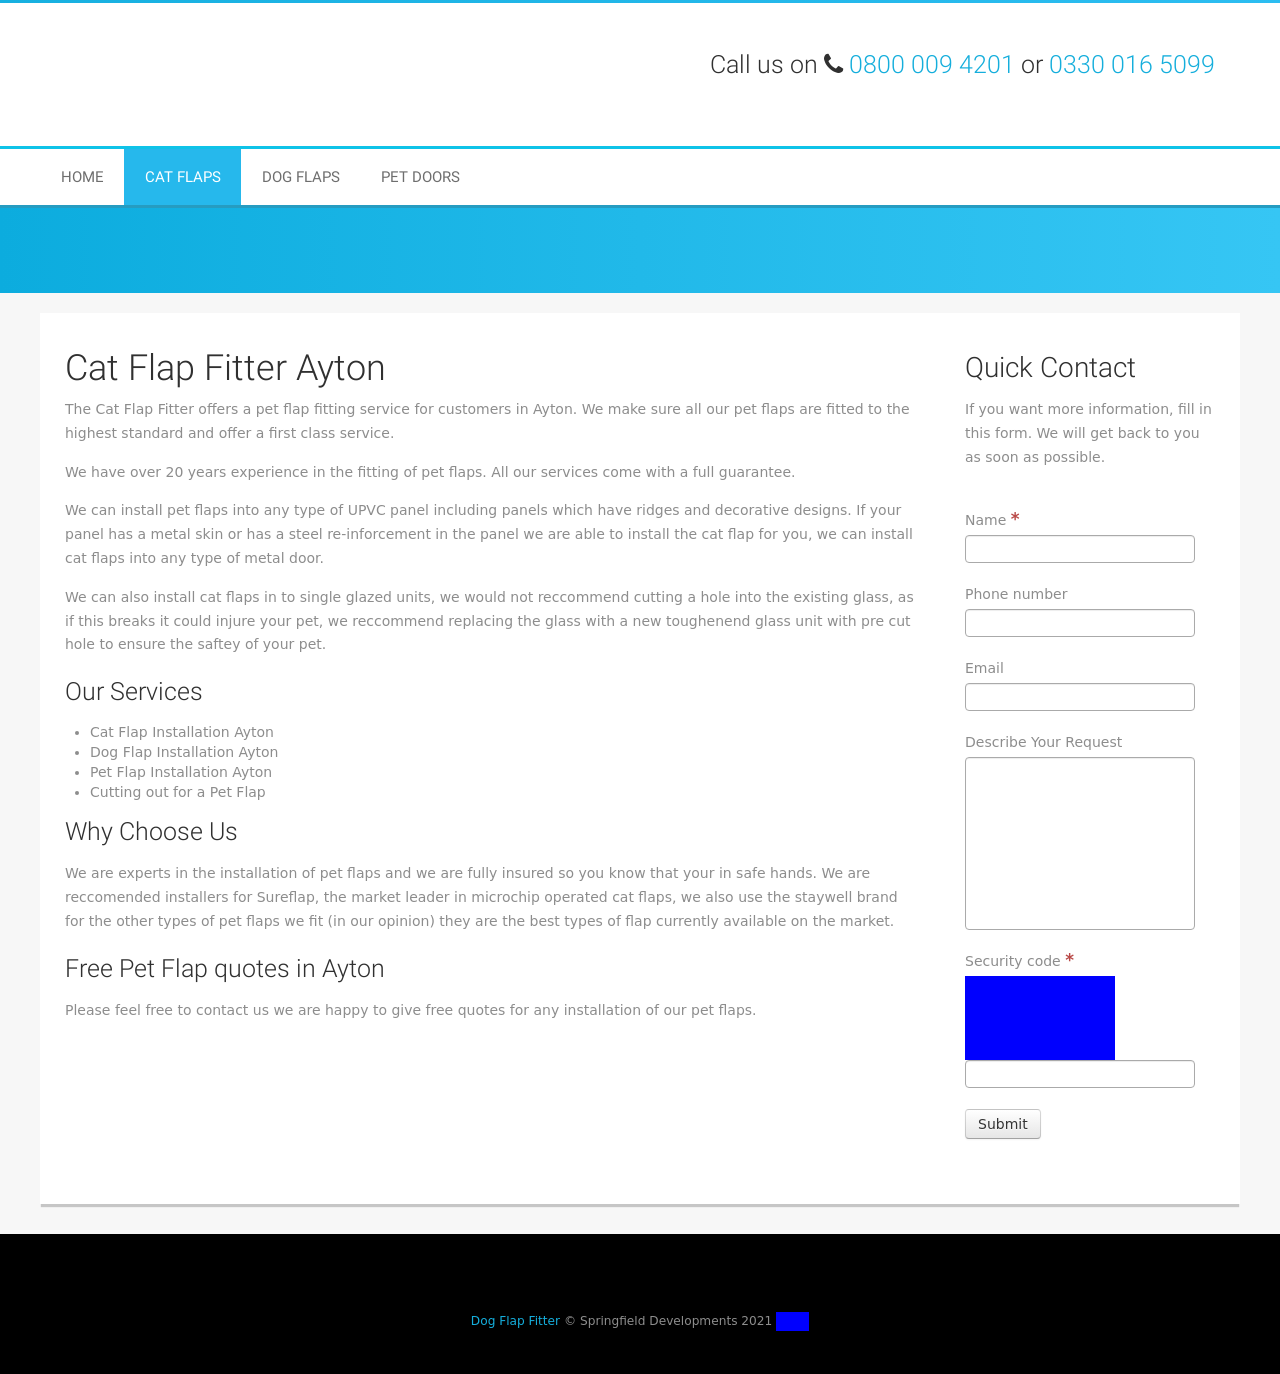What type of materials is this website promoting for pet flap installations? The website promotes pet flap installations into various materials such as UPVC panels, metal doors, and single glazed units. It emphasizes a specialized service that includes installing pet flaps into doors with ridges, decorative designs, and even metal reinforcements. 